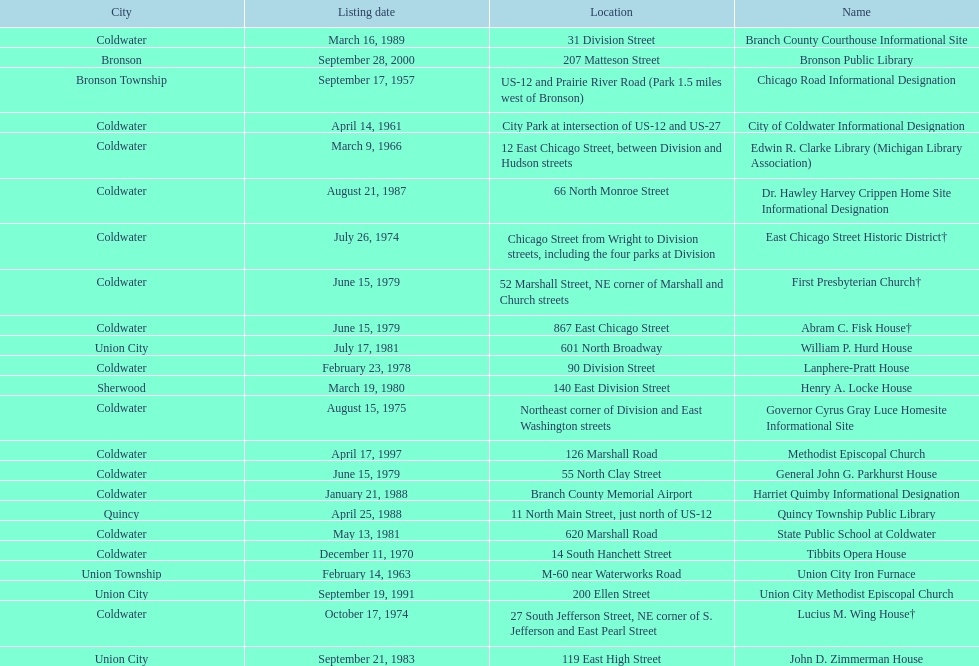How many sites are in coldwater? 15. 